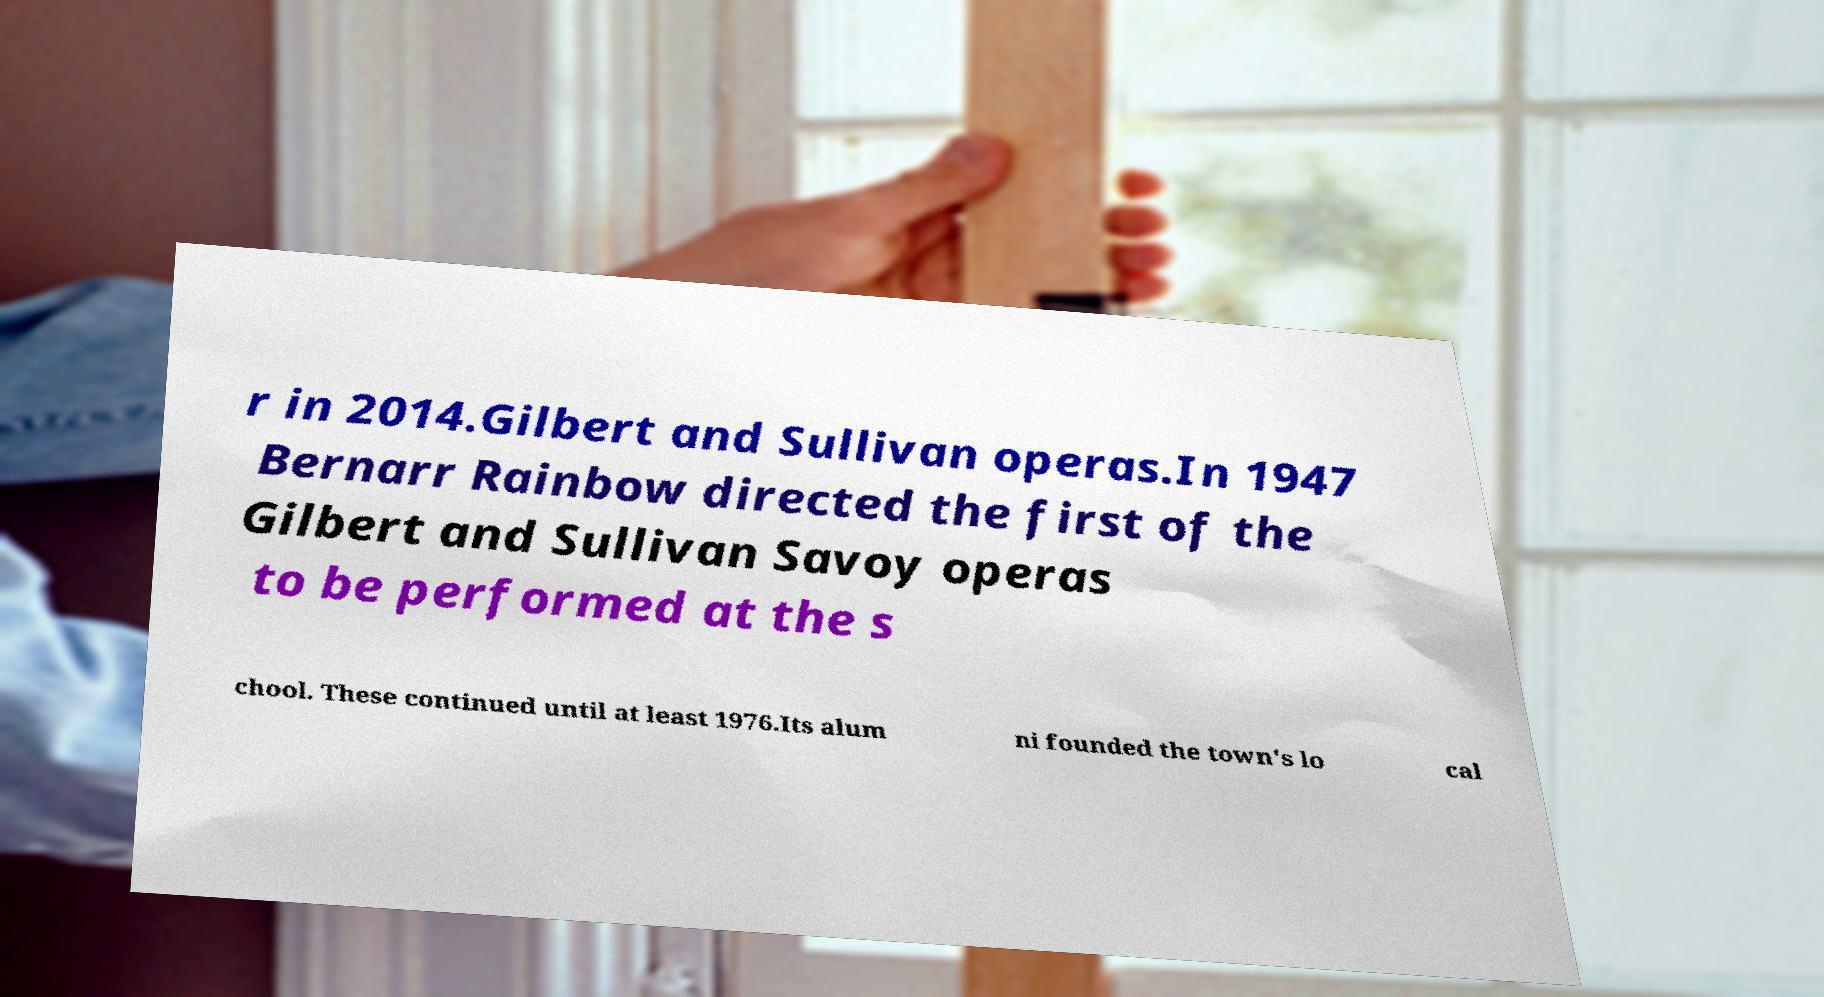Could you extract and type out the text from this image? r in 2014.Gilbert and Sullivan operas.In 1947 Bernarr Rainbow directed the first of the Gilbert and Sullivan Savoy operas to be performed at the s chool. These continued until at least 1976.Its alum ni founded the town's lo cal 